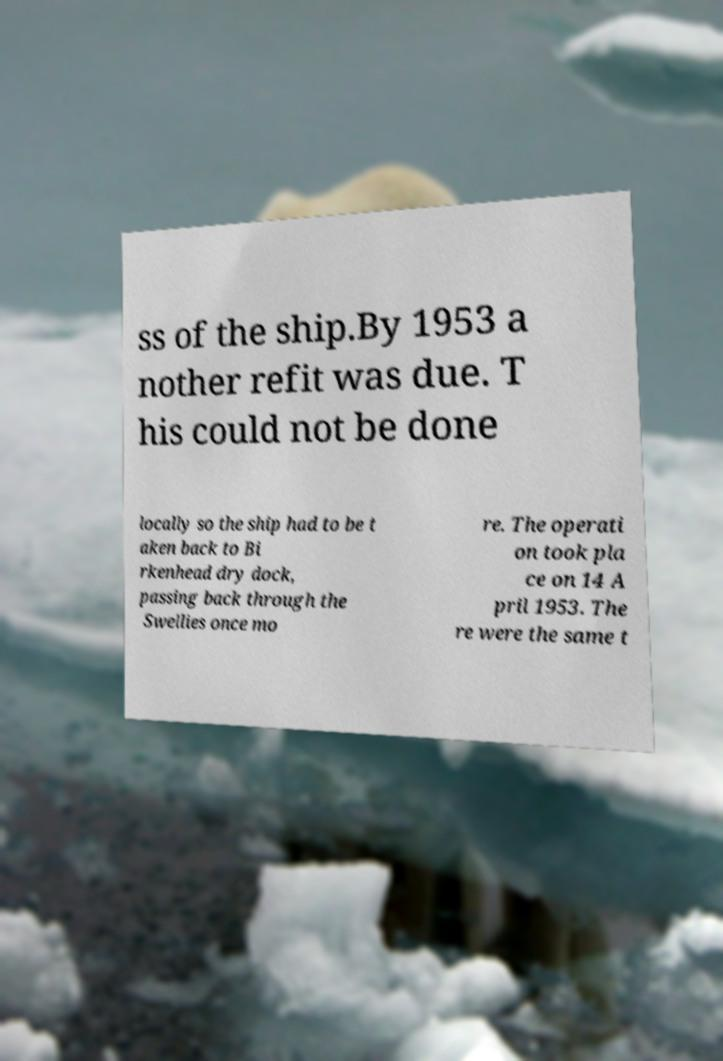Can you accurately transcribe the text from the provided image for me? ss of the ship.By 1953 a nother refit was due. T his could not be done locally so the ship had to be t aken back to Bi rkenhead dry dock, passing back through the Swellies once mo re. The operati on took pla ce on 14 A pril 1953. The re were the same t 